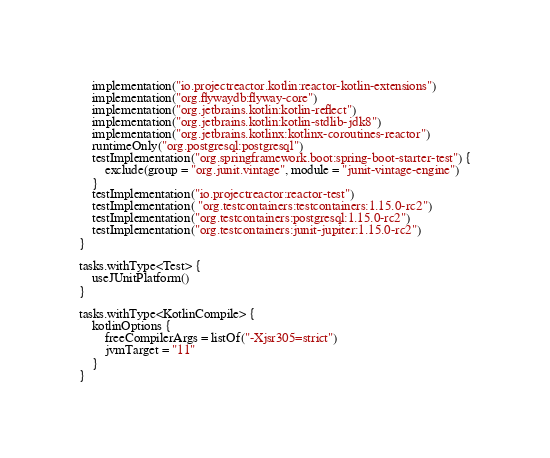<code> <loc_0><loc_0><loc_500><loc_500><_Kotlin_>	implementation("io.projectreactor.kotlin:reactor-kotlin-extensions")
	implementation("org.flywaydb:flyway-core")
	implementation("org.jetbrains.kotlin:kotlin-reflect")
	implementation("org.jetbrains.kotlin:kotlin-stdlib-jdk8")
	implementation("org.jetbrains.kotlinx:kotlinx-coroutines-reactor")
	runtimeOnly("org.postgresql:postgresql")
	testImplementation("org.springframework.boot:spring-boot-starter-test") {
		exclude(group = "org.junit.vintage", module = "junit-vintage-engine")
	}
	testImplementation("io.projectreactor:reactor-test")
	testImplementation( "org.testcontainers:testcontainers:1.15.0-rc2")
	testImplementation("org.testcontainers:postgresql:1.15.0-rc2")
	testImplementation("org.testcontainers:junit-jupiter:1.15.0-rc2")
}

tasks.withType<Test> {
	useJUnitPlatform()
}

tasks.withType<KotlinCompile> {
	kotlinOptions {
		freeCompilerArgs = listOf("-Xjsr305=strict")
		jvmTarget = "11"
	}
}
</code> 